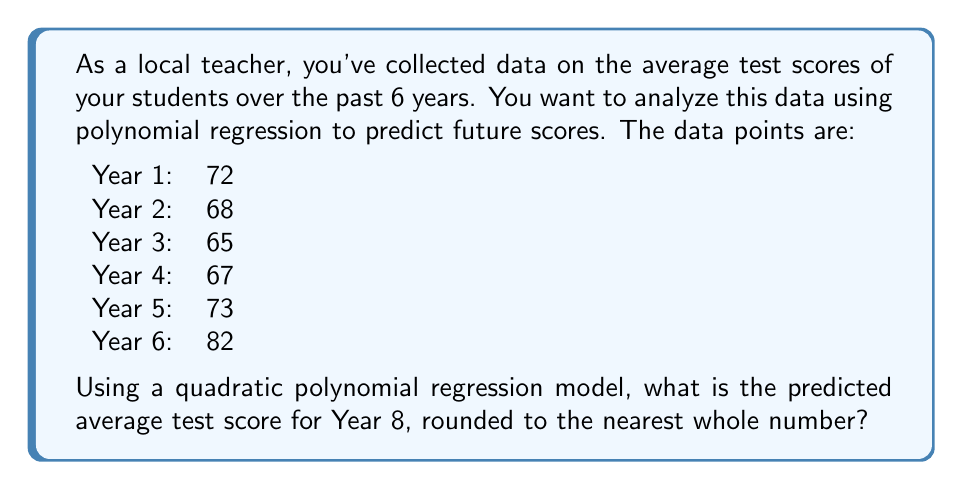Can you solve this math problem? Let's approach this step-by-step:

1) For a quadratic polynomial regression, we use the model:
   $y = ax^2 + bx + c$
   where $y$ is the test score and $x$ is the year number.

2) To find $a$, $b$, and $c$, we need to solve a system of normal equations. However, for simplicity, we'll use a calculator or spreadsheet software to find these values.

3) Using a regression calculator, we get:
   $a = 1.9286$
   $b = -8.6429$
   $c = 78.9286$

4) Our quadratic model is:
   $y = 1.9286x^2 - 8.6429x + 78.9286$

5) To predict the score for Year 8, we substitute $x = 8$:

   $y = 1.9286(8^2) - 8.6429(8) + 78.9286$
   $y = 1.9286(64) - 8.6429(8) + 78.9286$
   $y = 123.4304 - 69.1432 + 78.9286$
   $y = 133.2158$

6) Rounding to the nearest whole number:
   $y \approx 133$

This result shows a significant increase from the last observed year, which might raise skepticism. As a practical teacher, you should consider whether such a dramatic increase is realistic or if there might be limitations to this model for long-term predictions.
Answer: 133 